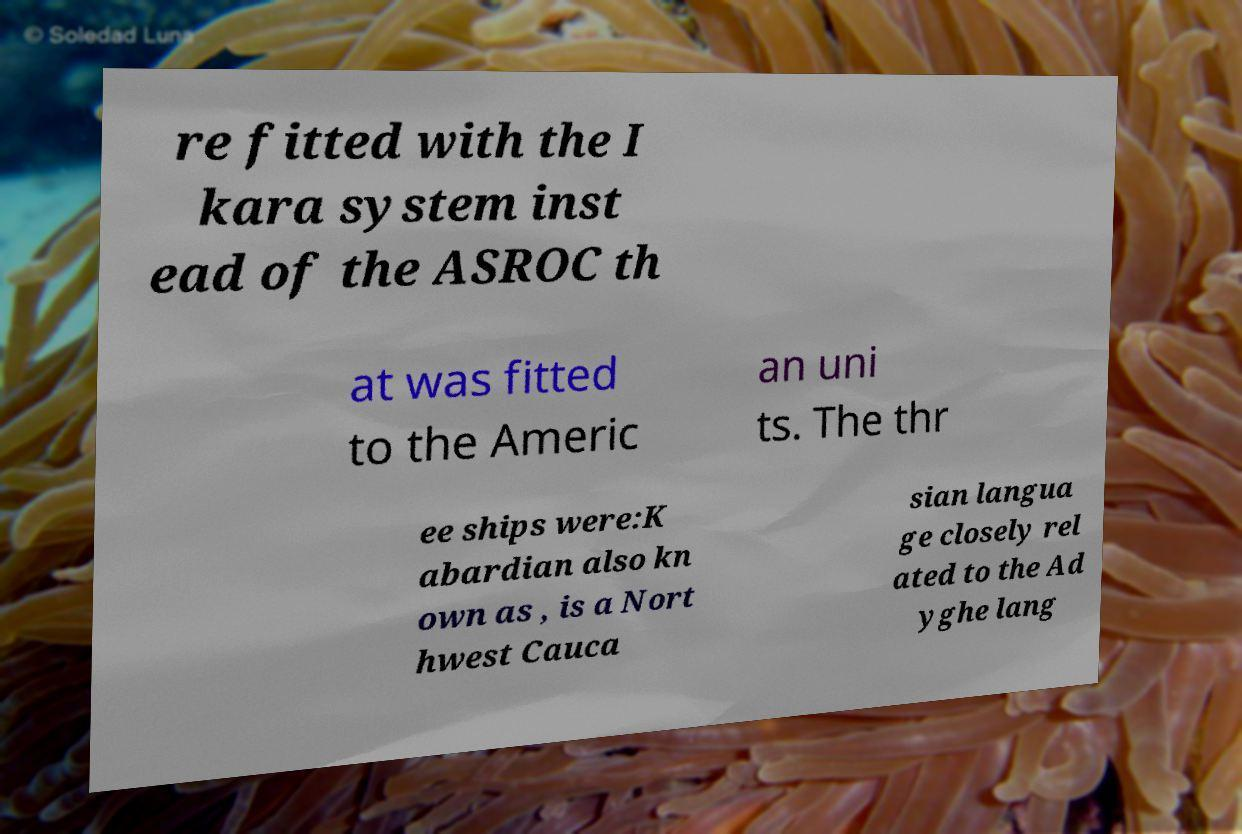Could you assist in decoding the text presented in this image and type it out clearly? re fitted with the I kara system inst ead of the ASROC th at was fitted to the Americ an uni ts. The thr ee ships were:K abardian also kn own as , is a Nort hwest Cauca sian langua ge closely rel ated to the Ad yghe lang 